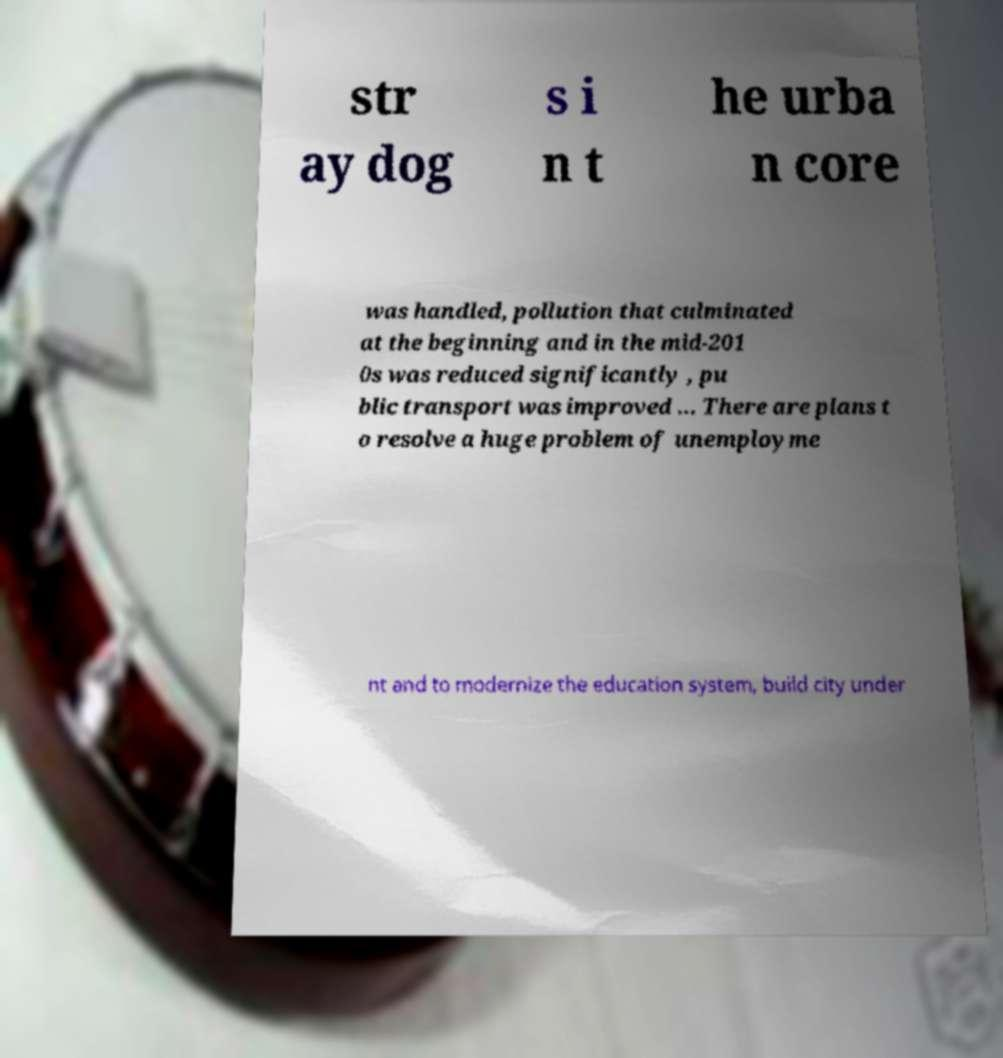I need the written content from this picture converted into text. Can you do that? str ay dog s i n t he urba n core was handled, pollution that culminated at the beginning and in the mid-201 0s was reduced significantly , pu blic transport was improved ... There are plans t o resolve a huge problem of unemployme nt and to modernize the education system, build city under 